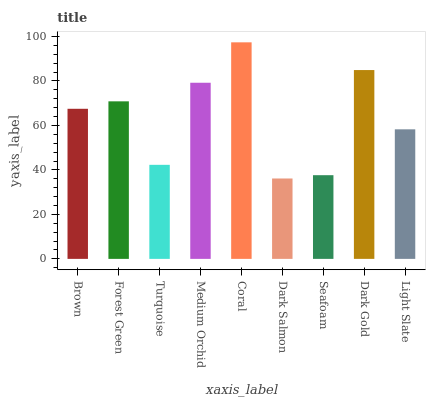Is Dark Salmon the minimum?
Answer yes or no. Yes. Is Coral the maximum?
Answer yes or no. Yes. Is Forest Green the minimum?
Answer yes or no. No. Is Forest Green the maximum?
Answer yes or no. No. Is Forest Green greater than Brown?
Answer yes or no. Yes. Is Brown less than Forest Green?
Answer yes or no. Yes. Is Brown greater than Forest Green?
Answer yes or no. No. Is Forest Green less than Brown?
Answer yes or no. No. Is Brown the high median?
Answer yes or no. Yes. Is Brown the low median?
Answer yes or no. Yes. Is Forest Green the high median?
Answer yes or no. No. Is Turquoise the low median?
Answer yes or no. No. 